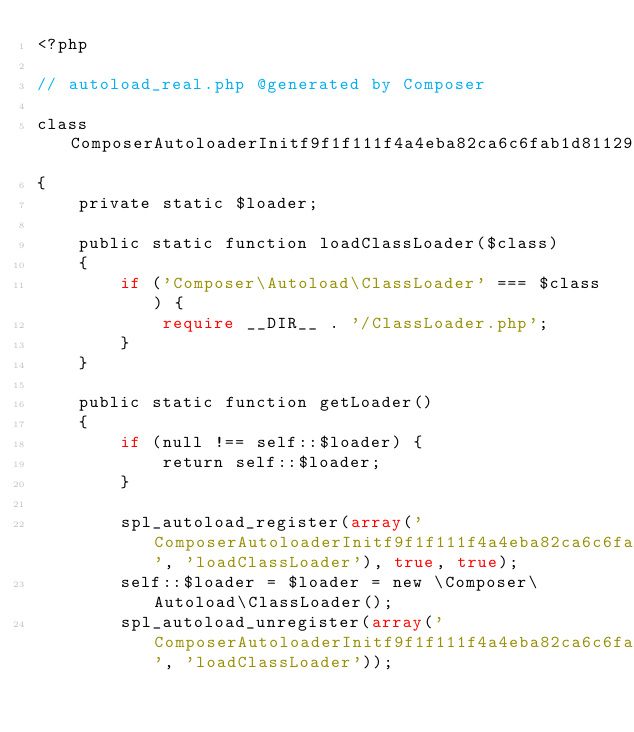<code> <loc_0><loc_0><loc_500><loc_500><_PHP_><?php

// autoload_real.php @generated by Composer

class ComposerAutoloaderInitf9f1f111f4a4eba82ca6c6fab1d81129
{
    private static $loader;

    public static function loadClassLoader($class)
    {
        if ('Composer\Autoload\ClassLoader' === $class) {
            require __DIR__ . '/ClassLoader.php';
        }
    }

    public static function getLoader()
    {
        if (null !== self::$loader) {
            return self::$loader;
        }

        spl_autoload_register(array('ComposerAutoloaderInitf9f1f111f4a4eba82ca6c6fab1d81129', 'loadClassLoader'), true, true);
        self::$loader = $loader = new \Composer\Autoload\ClassLoader();
        spl_autoload_unregister(array('ComposerAutoloaderInitf9f1f111f4a4eba82ca6c6fab1d81129', 'loadClassLoader'));
</code> 